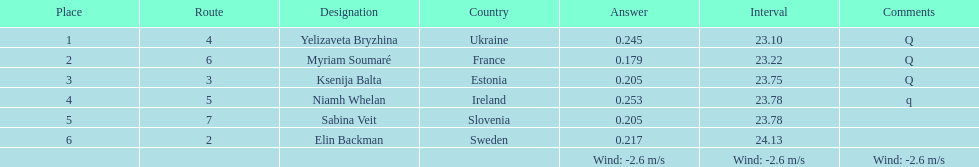Are there any sequentially ordered lanes? No. 